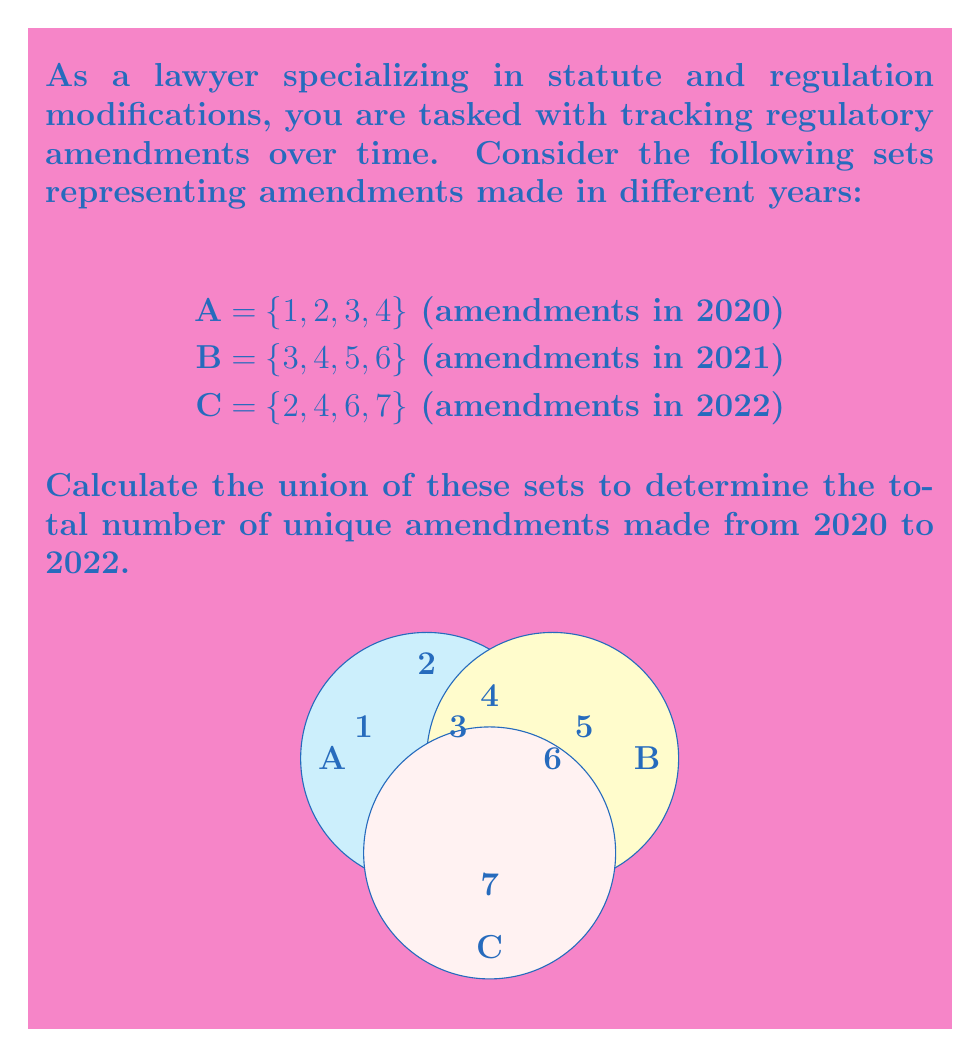Solve this math problem. To solve this problem, we need to find the union of sets A, B, and C. The union of sets includes all unique elements from all sets. Let's approach this step-by-step:

1) First, let's write out the sets:
   A = {1, 2, 3, 4}
   B = {3, 4, 5, 6}
   C = {2, 4, 6, 7}

2) Now, let's find the union A ∪ B ∪ C. We'll start with A and add unique elements from B and C:

   - Start with A: {1, 2, 3, 4}
   - Add unique elements from B: 5 and 6
   - Add unique elements from C: 7 (2 and 6 are already included)

3) Therefore, A ∪ B ∪ C = {1, 2, 3, 4, 5, 6, 7}

4) To find the total number of unique amendments, we simply count the elements in this set.

5) The set A ∪ B ∪ C has 7 elements.

In set notation, we can write this as:

$$ |A \cup B \cup C| = 7 $$

where $|...|$ denotes the cardinality (number of elements) of the set.
Answer: 7 